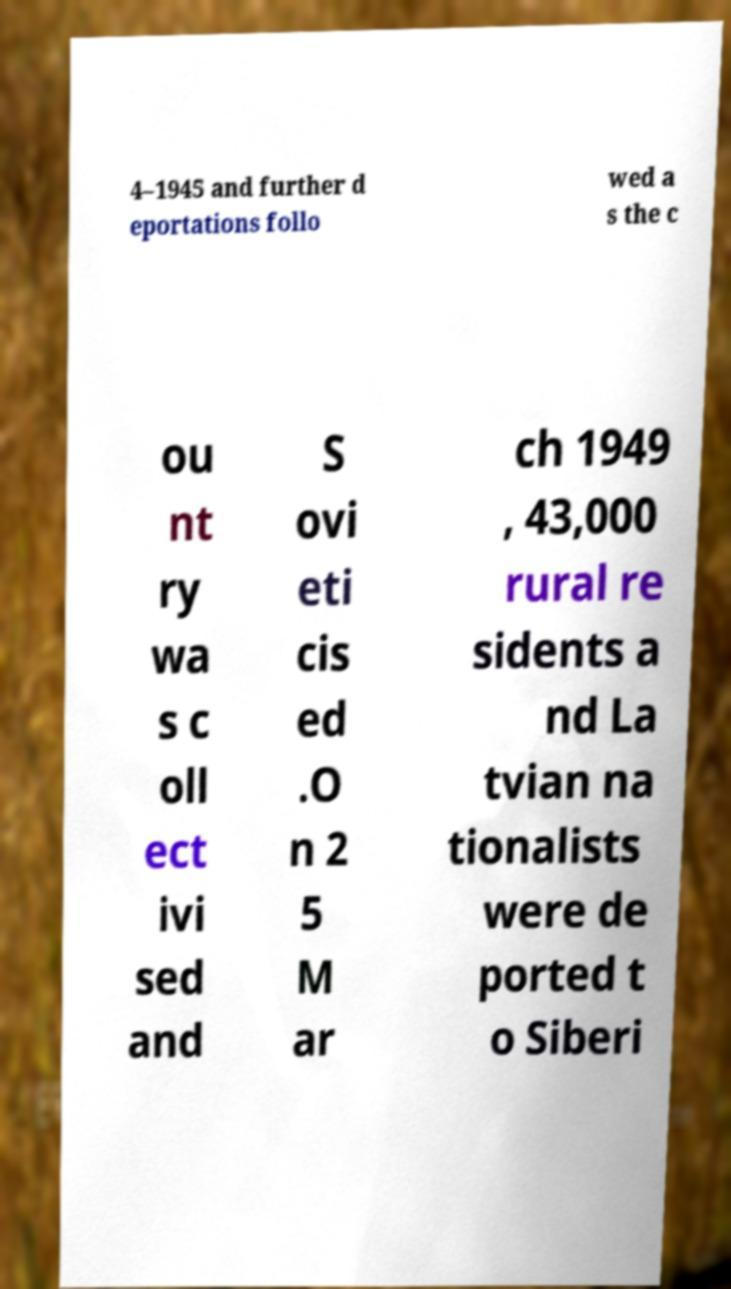Can you read and provide the text displayed in the image?This photo seems to have some interesting text. Can you extract and type it out for me? 4–1945 and further d eportations follo wed a s the c ou nt ry wa s c oll ect ivi sed and S ovi eti cis ed .O n 2 5 M ar ch 1949 , 43,000 rural re sidents a nd La tvian na tionalists were de ported t o Siberi 